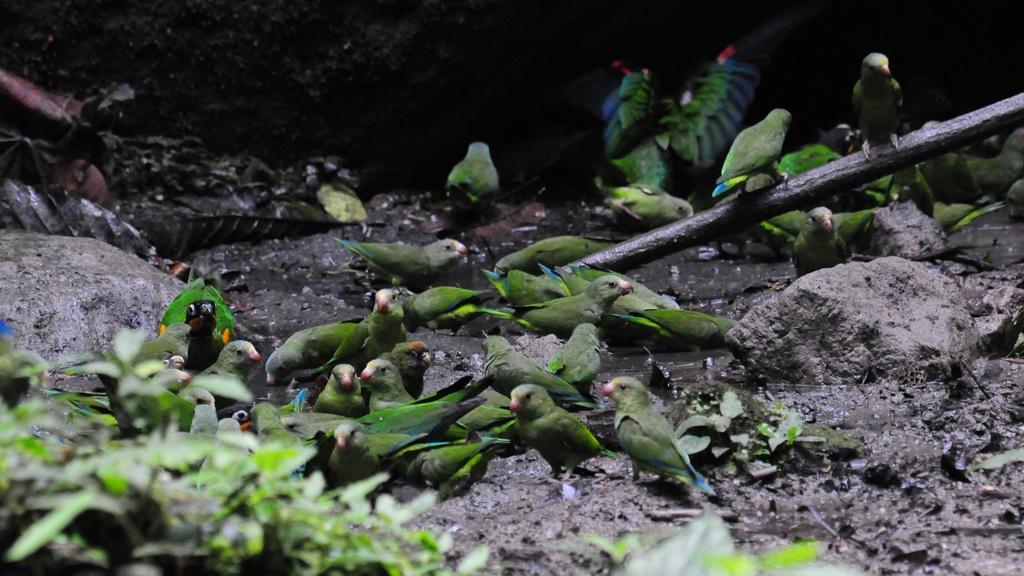Please provide a concise description of this image. In this picture I can see birds standing on the mud, there are rocks, plants, and it looks like a rod. 